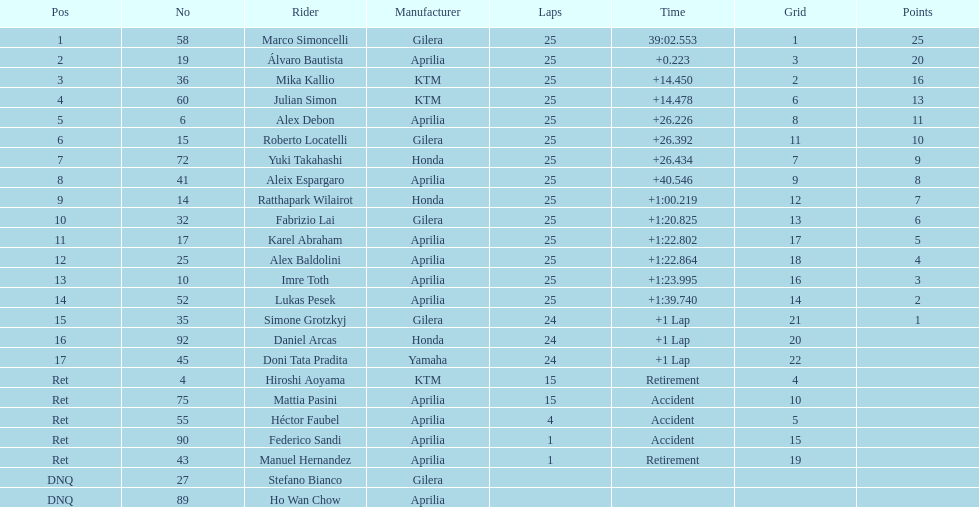What is the overall count of riders? 24. 